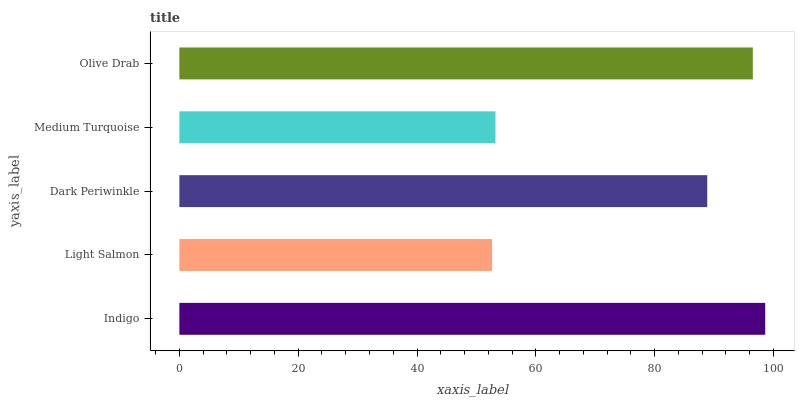Is Light Salmon the minimum?
Answer yes or no. Yes. Is Indigo the maximum?
Answer yes or no. Yes. Is Dark Periwinkle the minimum?
Answer yes or no. No. Is Dark Periwinkle the maximum?
Answer yes or no. No. Is Dark Periwinkle greater than Light Salmon?
Answer yes or no. Yes. Is Light Salmon less than Dark Periwinkle?
Answer yes or no. Yes. Is Light Salmon greater than Dark Periwinkle?
Answer yes or no. No. Is Dark Periwinkle less than Light Salmon?
Answer yes or no. No. Is Dark Periwinkle the high median?
Answer yes or no. Yes. Is Dark Periwinkle the low median?
Answer yes or no. Yes. Is Light Salmon the high median?
Answer yes or no. No. Is Medium Turquoise the low median?
Answer yes or no. No. 